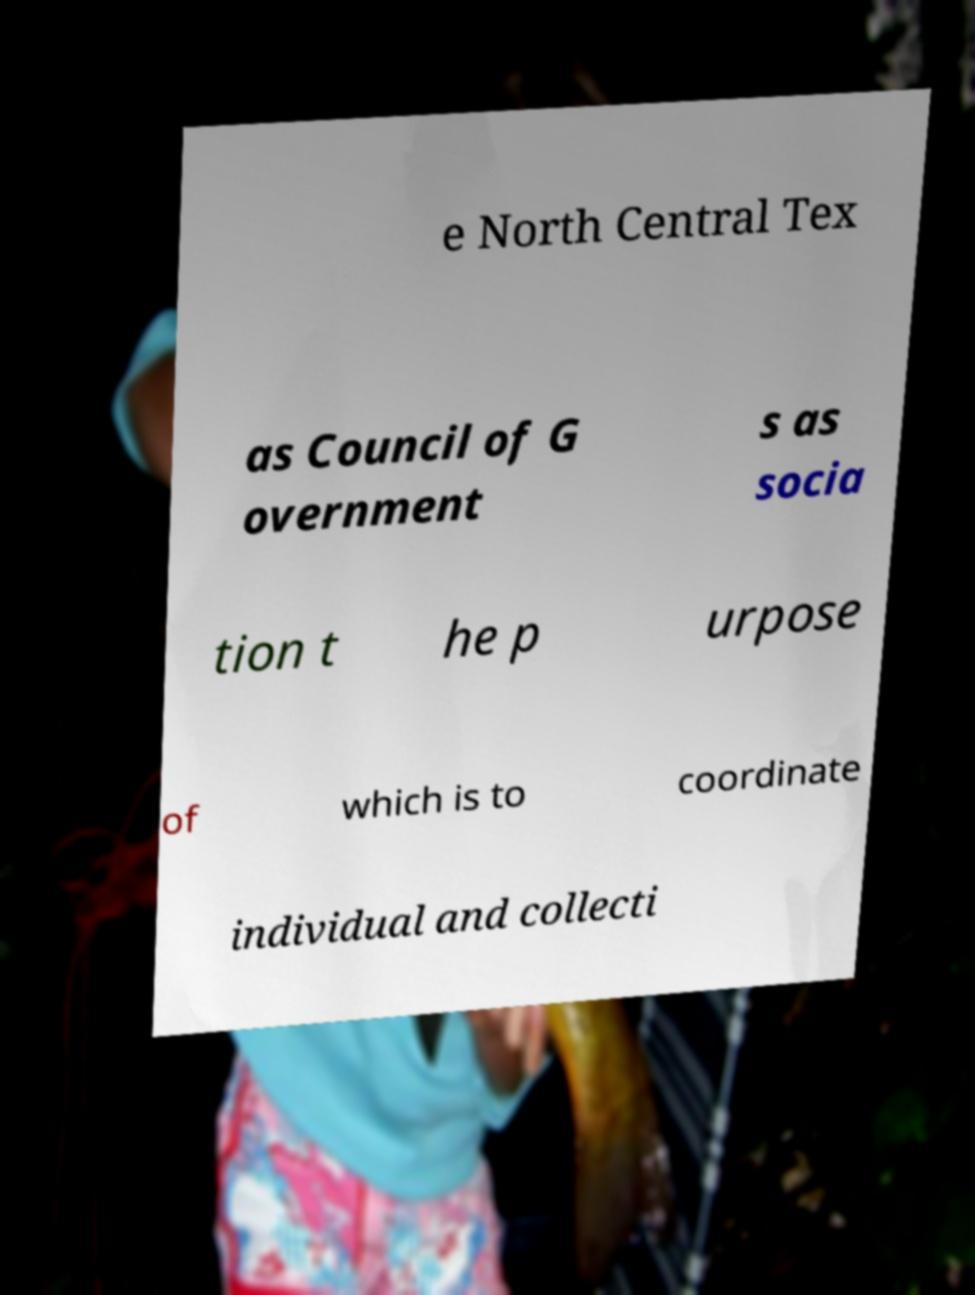I need the written content from this picture converted into text. Can you do that? e North Central Tex as Council of G overnment s as socia tion t he p urpose of which is to coordinate individual and collecti 